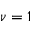<formula> <loc_0><loc_0><loc_500><loc_500>\nu = 1</formula> 